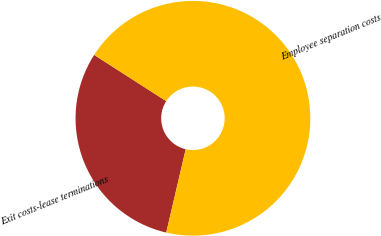<chart> <loc_0><loc_0><loc_500><loc_500><pie_chart><fcel>Exit costs-lease terminations<fcel>Employee separation costs<nl><fcel>30.43%<fcel>69.57%<nl></chart> 